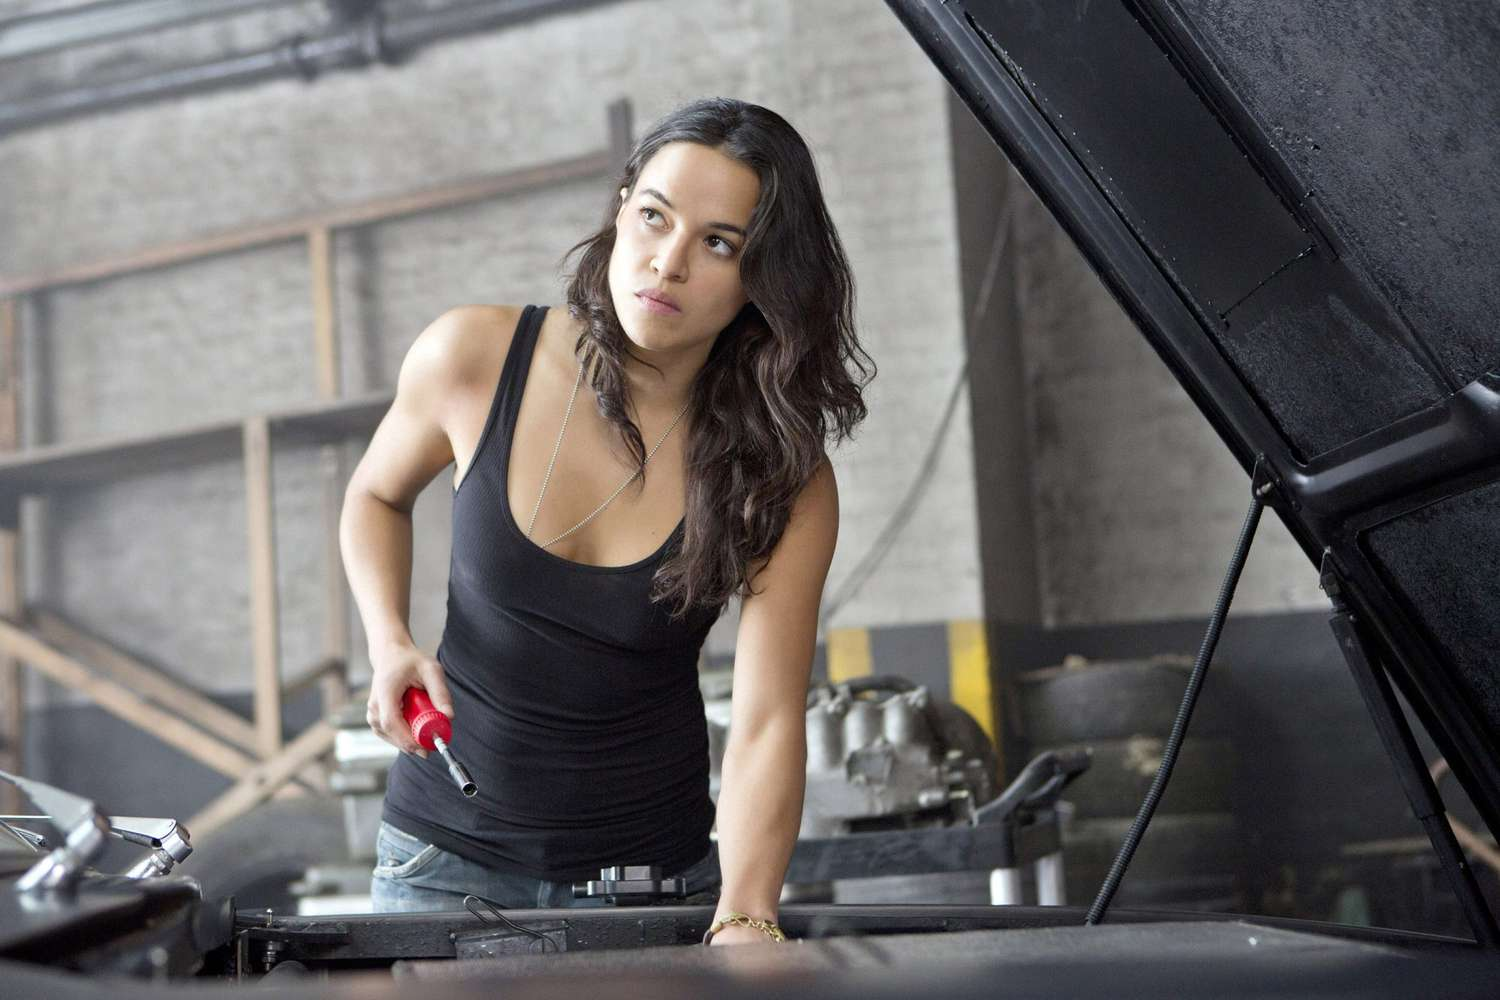Imagine a dramatic scenario involving this character in this setting. In this imagined scenario, the woman is preparing the car for a high-stakes underground race. Her team is depending on her mechanical expertise to tweak and boost the vehicle's performance, ensuring it can outpace the competition. Amid the ticking countdown of a race about to start, she works swiftly but precisely, every movement demonstrating her competence and commitment. As adrenaline builds, the muffled roars and cheers from outside contrast with the focused silence of the garage. The race represents more than just speed—it's about proving her skills and earning respect in a predominantly male-dominated field. 